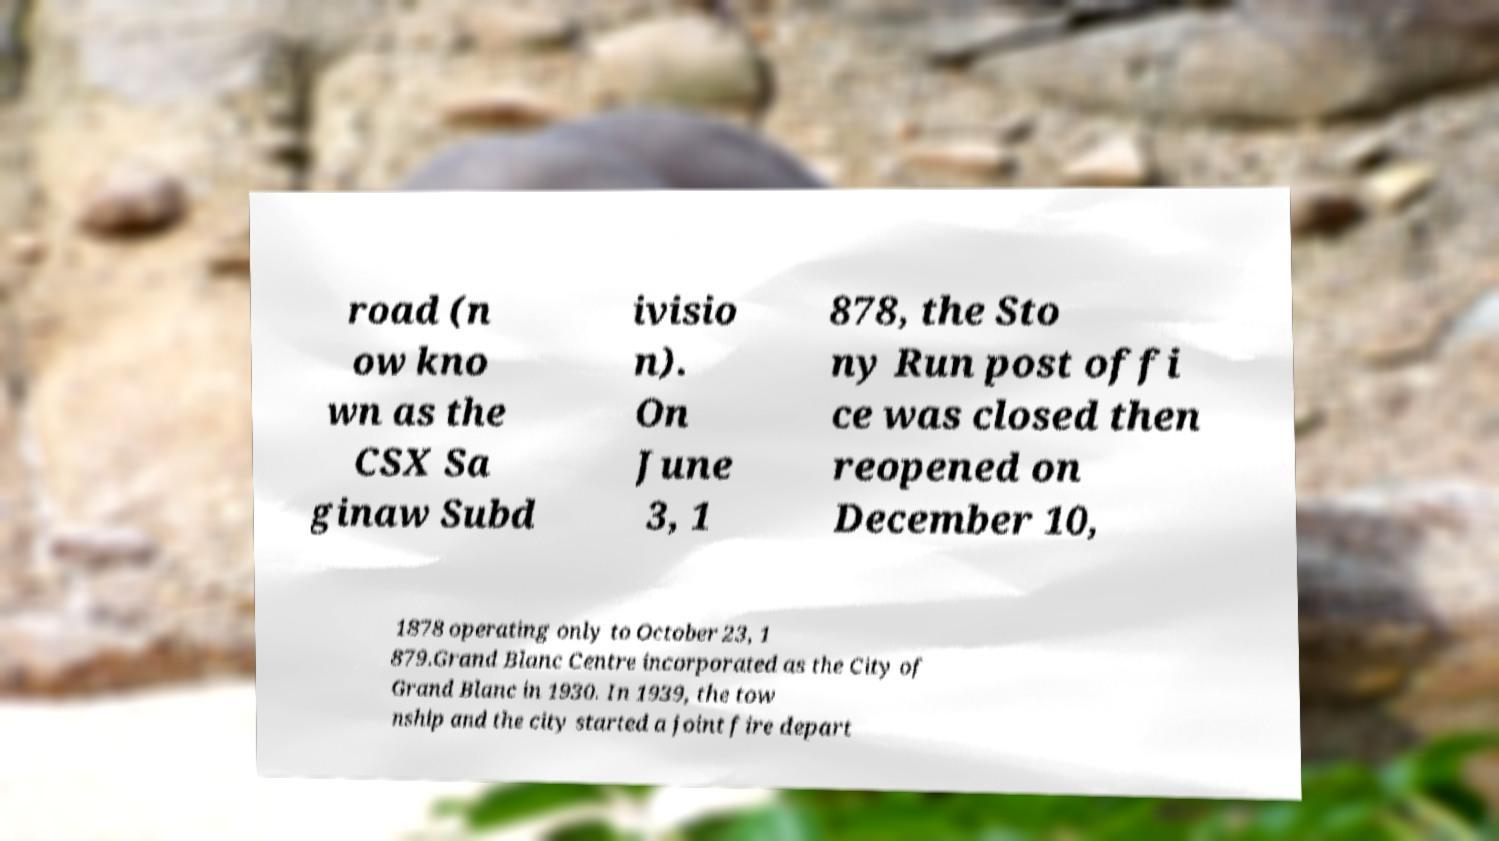For documentation purposes, I need the text within this image transcribed. Could you provide that? road (n ow kno wn as the CSX Sa ginaw Subd ivisio n). On June 3, 1 878, the Sto ny Run post offi ce was closed then reopened on December 10, 1878 operating only to October 23, 1 879.Grand Blanc Centre incorporated as the City of Grand Blanc in 1930. In 1939, the tow nship and the city started a joint fire depart 